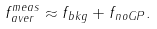<formula> <loc_0><loc_0><loc_500><loc_500>f _ { a v e r } ^ { m e a s } \approx f _ { b k g } + f _ { n o G P } .</formula> 